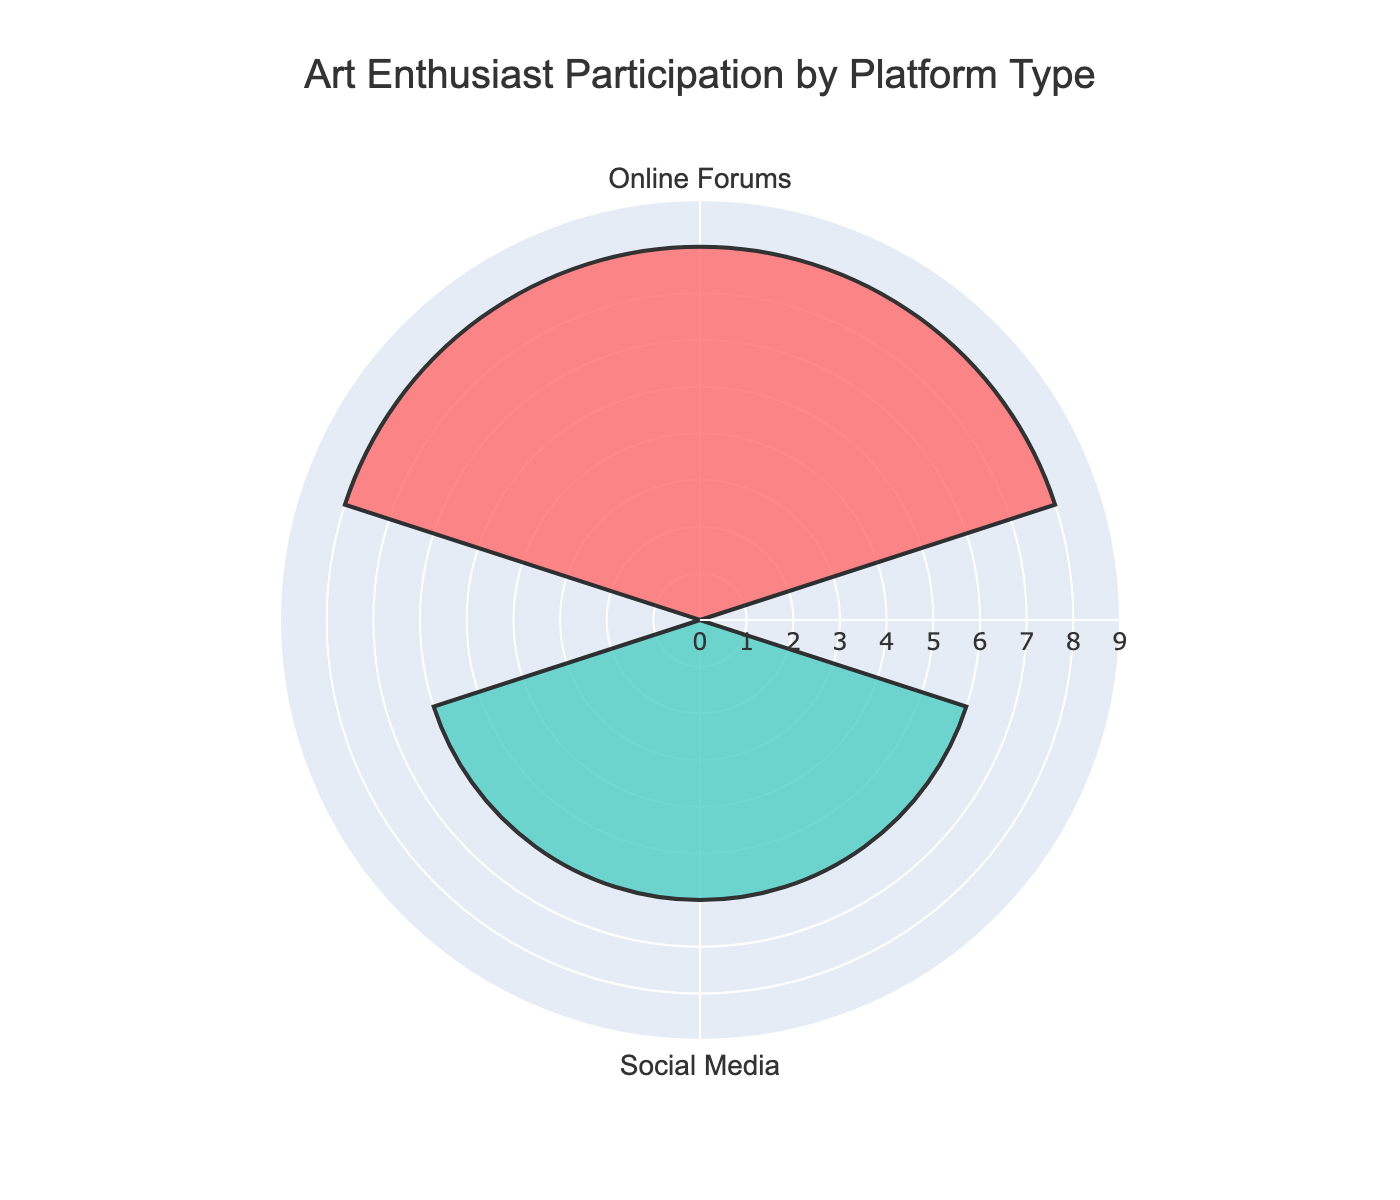What is the title of the figure? The title is located prominently at the top of the figure and is usually the most obvious text, indicating the overall theme or subject.
Answer: Art Enthusiast Participation by Platform Type Which platform group has a higher participation, Social Media or Online Forums? By looking at the lengths of the bars, we can compare the total sum of hours for the two groups.
Answer: Online Forums What is the total weekly participation for the Social Media group? The Social Media group includes Instagram and Facebook Groups. Summing their participation hours gives 4 + 2.
Answer: 6 hours How much more participation do Online Forums have compared to Social Media? First, sum the participation hours for both Online Forums (3 + 5 = 8) and Social Media (4 + 2 = 6). Then, subtract the total hours of Social Media from Online Forums.
Answer: 2 hours Which platform has the highest weekly participation? By visually comparing the lengths of the bars, we identify the platform with the longest bar.
Answer: DeviantArt How does Reddit's participation compare to Facebook Groups? Compare the bar lengths for Reddit and Facebook Groups.
Answer: Reddit has 1 more hour than Facebook Groups What is the average weekly participation for the platforms in the Online Forums group? Add the weekly participation for the Online Forums platforms (3 + 5 = 8) and then divide by the number of platforms (2).
Answer: 4 hours What color represents the Social Media group in the rose chart? Identify the color of the bars associated with Social Media (Instagram and Facebook Groups) in the chart.
Answer: #FF6B6B (pink) What is the participation difference between Instagram and DeviantArt? Subtract the weekly participation of Instagram from DeviantArt.
Answer: 1 hour Which group has less than 7 hours of total participation? By examining the total participation hours for each group, we identify the group with less than 7 hours.
Answer: Social Media 